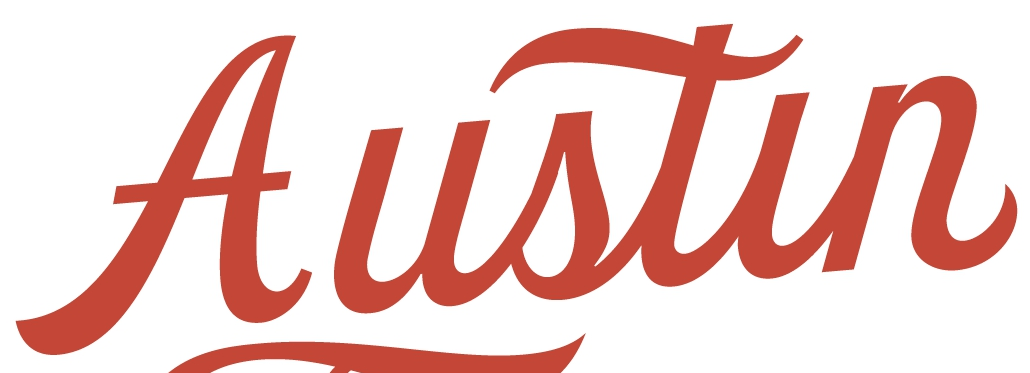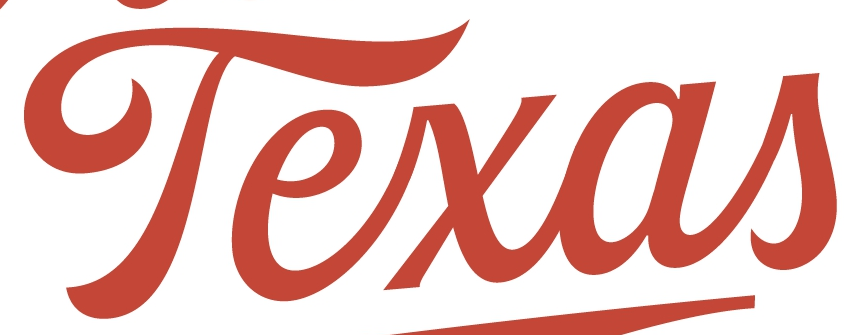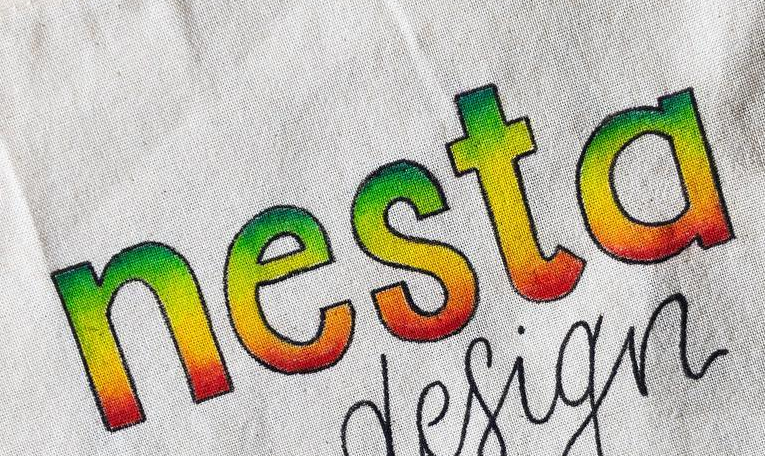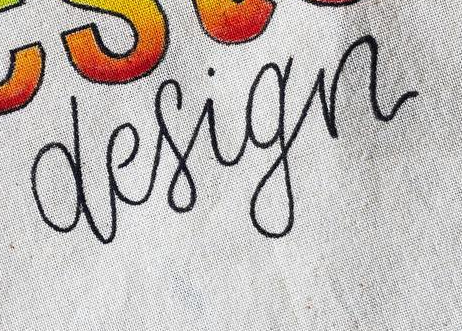Identify the words shown in these images in order, separated by a semicolon. Austin; Texas; nesta; design 